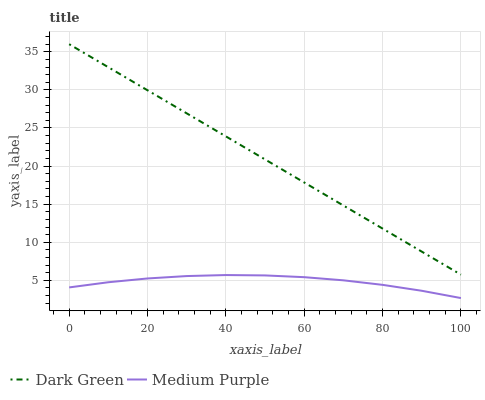Does Medium Purple have the minimum area under the curve?
Answer yes or no. Yes. Does Dark Green have the maximum area under the curve?
Answer yes or no. Yes. Does Dark Green have the minimum area under the curve?
Answer yes or no. No. Is Dark Green the smoothest?
Answer yes or no. Yes. Is Medium Purple the roughest?
Answer yes or no. Yes. Is Dark Green the roughest?
Answer yes or no. No. Does Dark Green have the lowest value?
Answer yes or no. No. Is Medium Purple less than Dark Green?
Answer yes or no. Yes. Is Dark Green greater than Medium Purple?
Answer yes or no. Yes. Does Medium Purple intersect Dark Green?
Answer yes or no. No. 